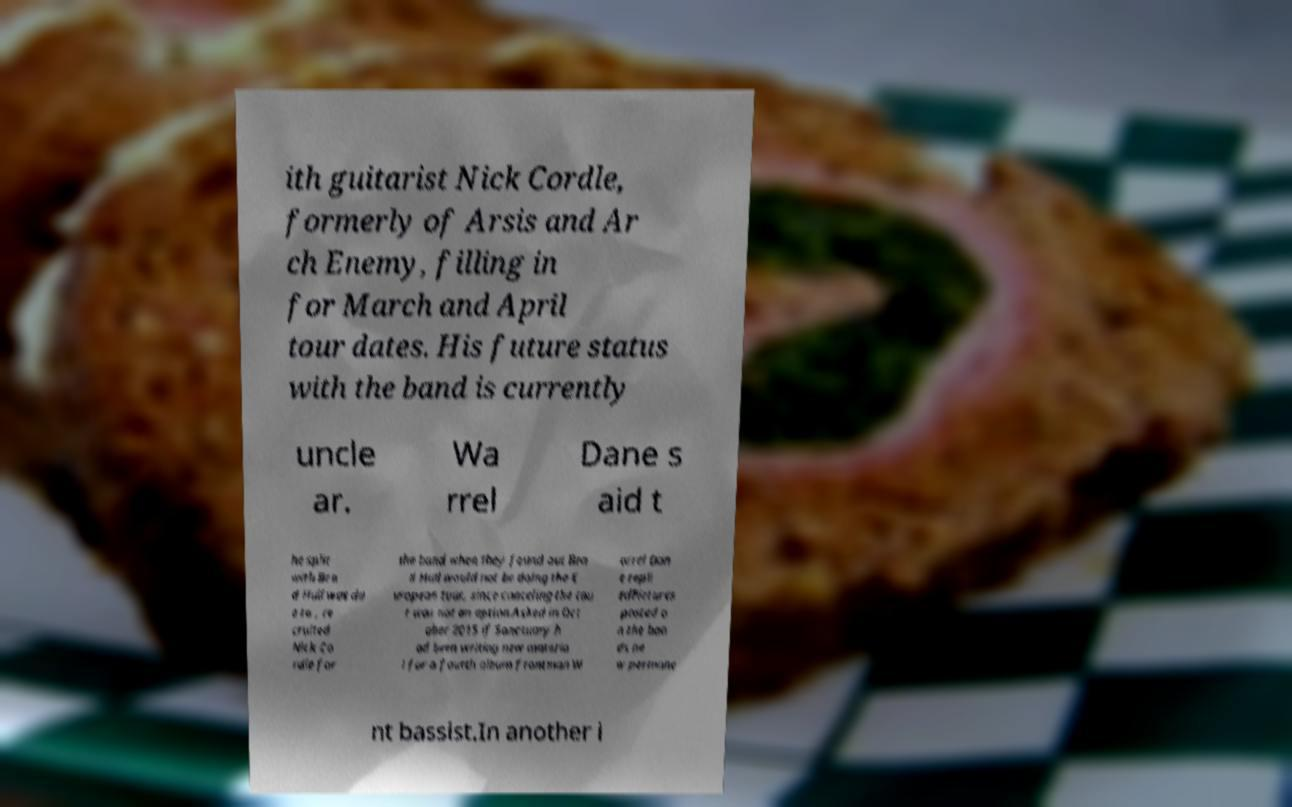Could you extract and type out the text from this image? ith guitarist Nick Cordle, formerly of Arsis and Ar ch Enemy, filling in for March and April tour dates. His future status with the band is currently uncle ar. Wa rrel Dane s aid t he split with Bra d Hull was du e to , re cruited Nick Co rdle for the band when they found out Bra d Hull would not be doing the E uropean tour, since canceling the tou r was not an option.Asked in Oct ober 2015 if Sanctuary h ad been writing new materia l for a fourth album frontman W arrel Dan e repli edPictures posted o n the ban ds ne w permane nt bassist.In another i 